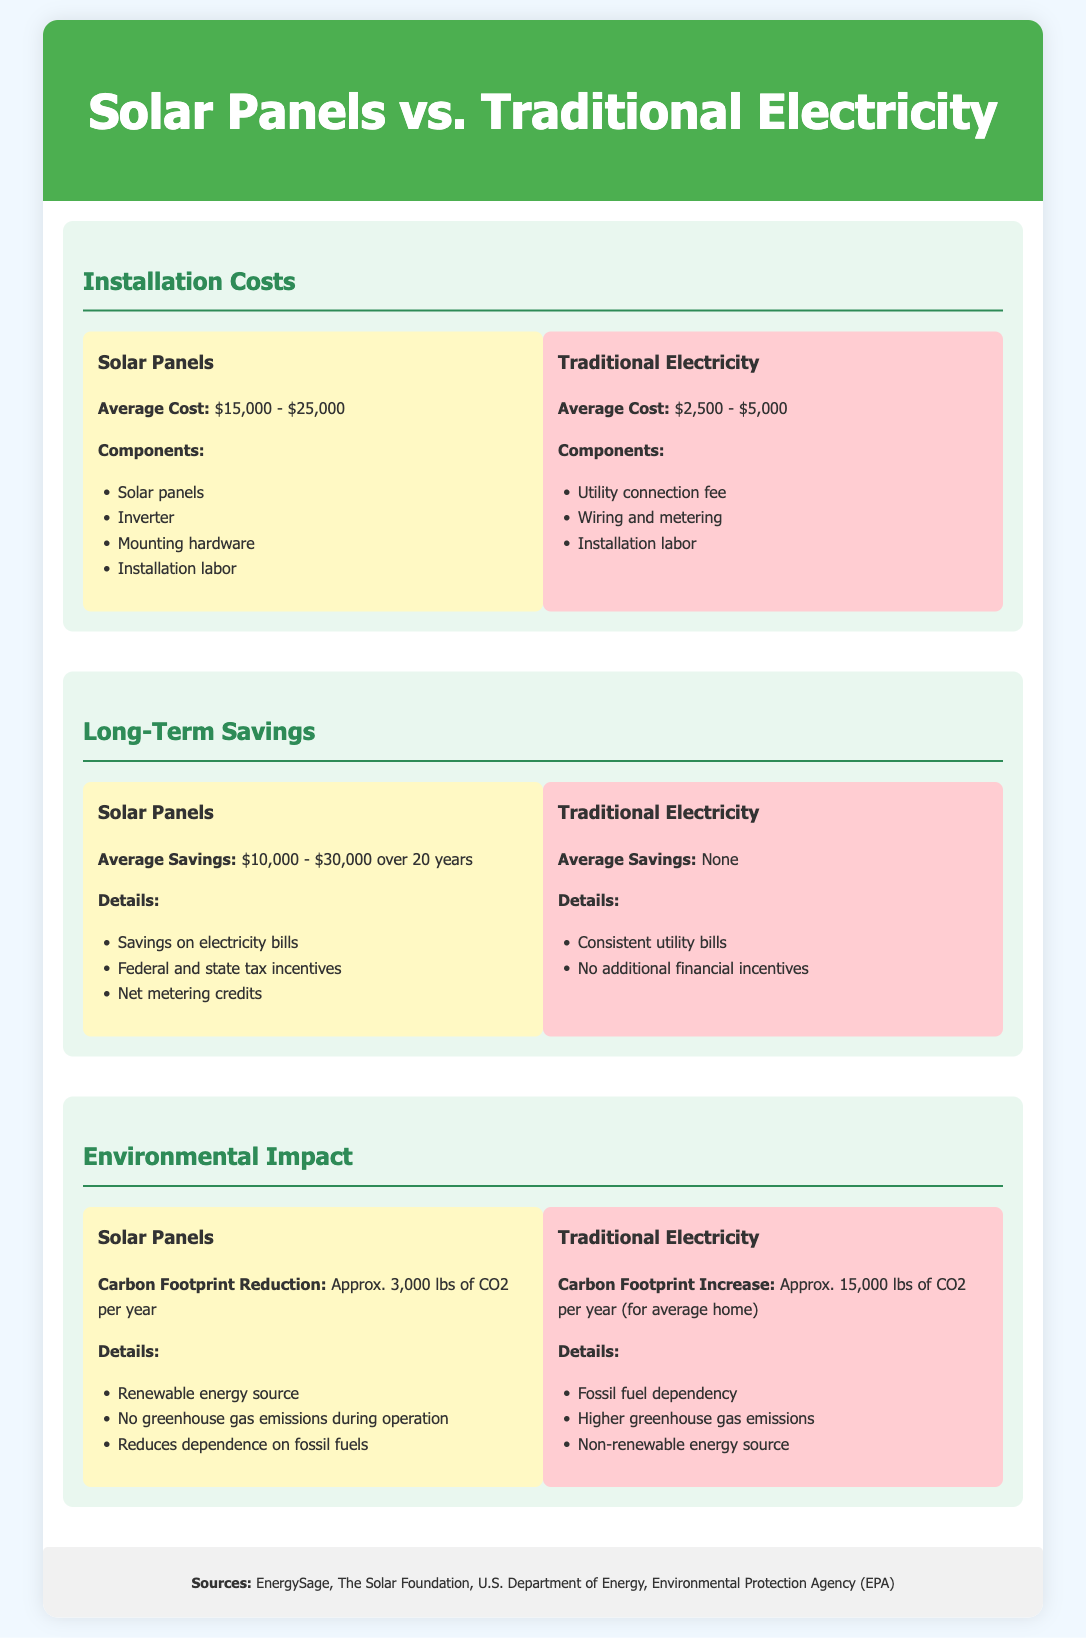What is the average installation cost of solar panels? The document states that the average installation cost for solar panels is between $15,000 and $25,000.
Answer: $15,000 - $25,000 What is the average installation cost of traditional electricity? The document mentions that the average installation cost for traditional electricity is between $2,500 and $5,000.
Answer: $2,500 - $5,000 How much can one save on average with solar panels over 20 years? The document indicates that the average savings with solar panels over 20 years is between $10,000 and $30,000.
Answer: $10,000 - $30,000 What is the carbon footprint reduction per year with solar panels? The document states that solar panels lead to an approximate reduction of 3,000 lbs of CO2 per year.
Answer: 3,000 lbs What is the average carbon footprint increase per year with traditional electricity? The document notes that traditional electricity results in an approximate increase of 15,000 lbs of CO2 per year for the average home.
Answer: 15,000 lbs What components are included in the installation of solar panels? The document lists solar panels, inverter, mounting hardware, and installation labor as components for solar panel installation.
Answer: Solar panels, inverter, mounting hardware, installation labor What type of energy source are solar panels categorized as? The document categorizes solar panels as a renewable energy source.
Answer: Renewable energy source What incentive is provided in traditional electricity? The document states that there are no additional financial incentives provided for traditional electricity.
Answer: None What are the greenhouse gas emissions during the operation of solar panels? The document indicates that solar panels have no greenhouse gas emissions during operation.
Answer: No greenhouse gas emissions 